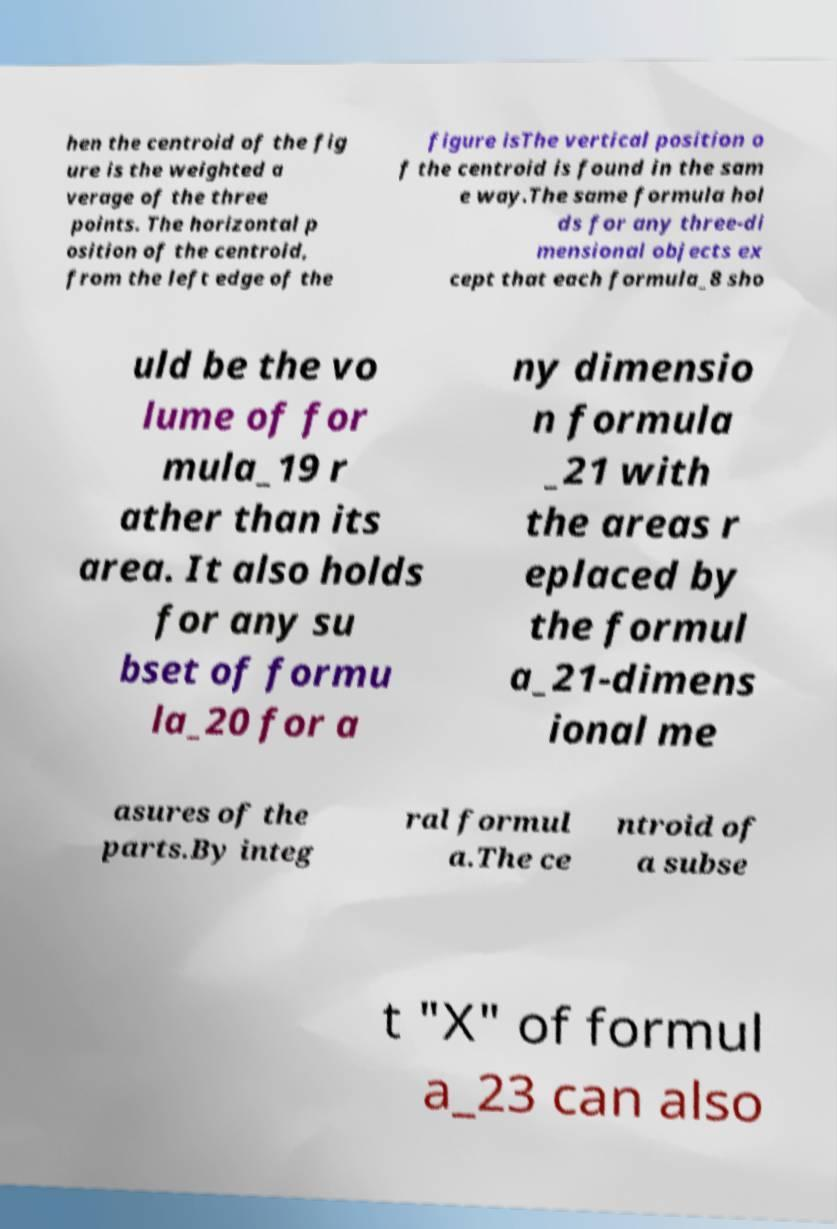For documentation purposes, I need the text within this image transcribed. Could you provide that? hen the centroid of the fig ure is the weighted a verage of the three points. The horizontal p osition of the centroid, from the left edge of the figure isThe vertical position o f the centroid is found in the sam e way.The same formula hol ds for any three-di mensional objects ex cept that each formula_8 sho uld be the vo lume of for mula_19 r ather than its area. It also holds for any su bset of formu la_20 for a ny dimensio n formula _21 with the areas r eplaced by the formul a_21-dimens ional me asures of the parts.By integ ral formul a.The ce ntroid of a subse t "X" of formul a_23 can also 